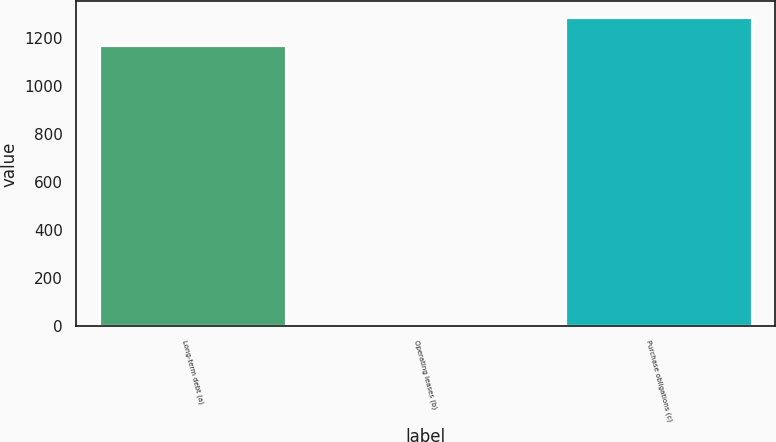Convert chart. <chart><loc_0><loc_0><loc_500><loc_500><bar_chart><fcel>Long-term debt (a)<fcel>Operating leases (b)<fcel>Purchase obligations (c)<nl><fcel>1168<fcel>2<fcel>1286.6<nl></chart> 